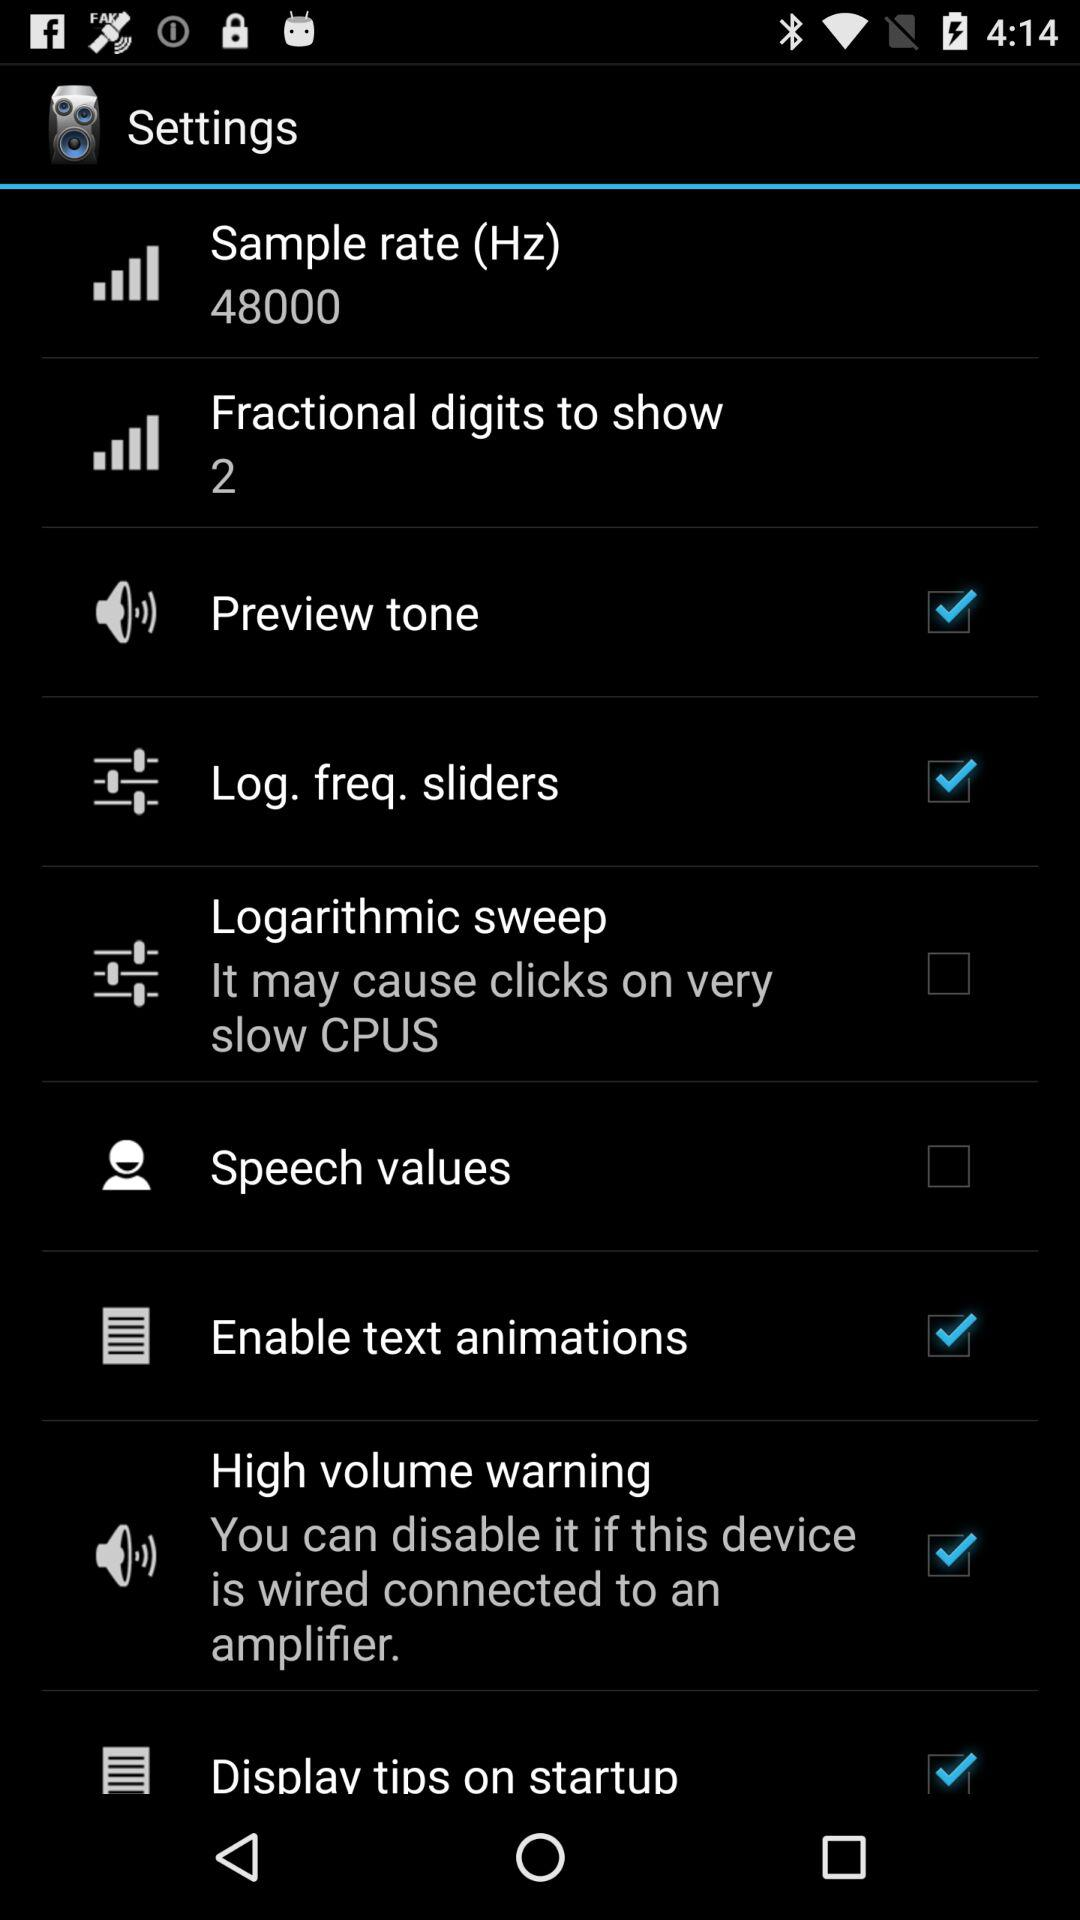What is the status of "Speech values"? The status is "off". 